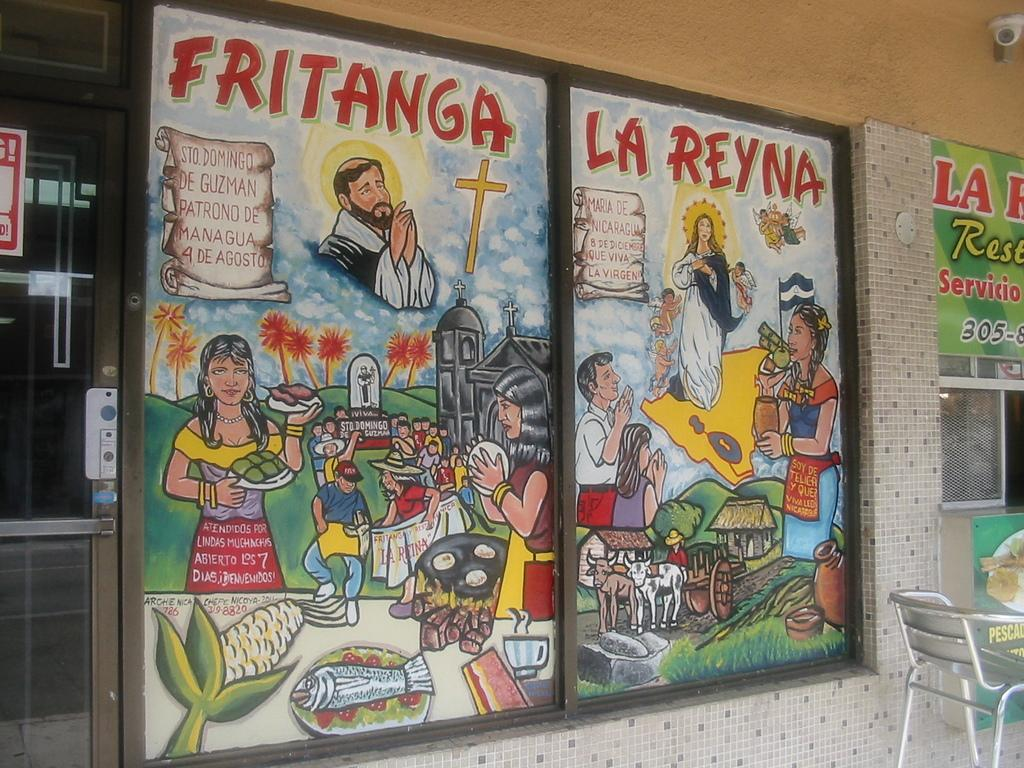<image>
Give a short and clear explanation of the subsequent image. A sign for Fritanga La Reyna features cartoon drawings of people. 